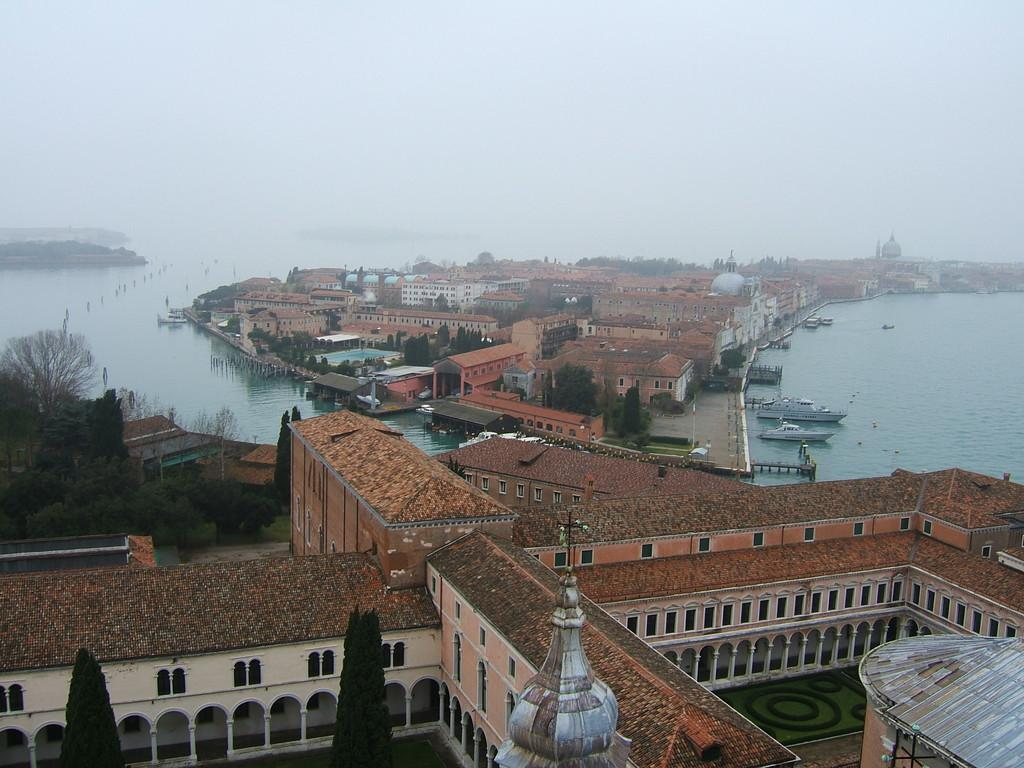What is in the water in the image? There are boats in the water in the image. What structures can be seen in the image? There are buildings in the image. What type of vegetation is present in the image? There are trees in the image. Are there any specific architectural features on the buildings? Some buildings have arches. What type of mint can be seen growing near the buildings in the image? There is no mint present in the image; it only features boats, buildings, trees, and arches on the buildings. What type of secretary can be seen working in one of the buildings in the image? There is no secretary present in the image; it only features boats, buildings, trees, and arches on the buildings. 